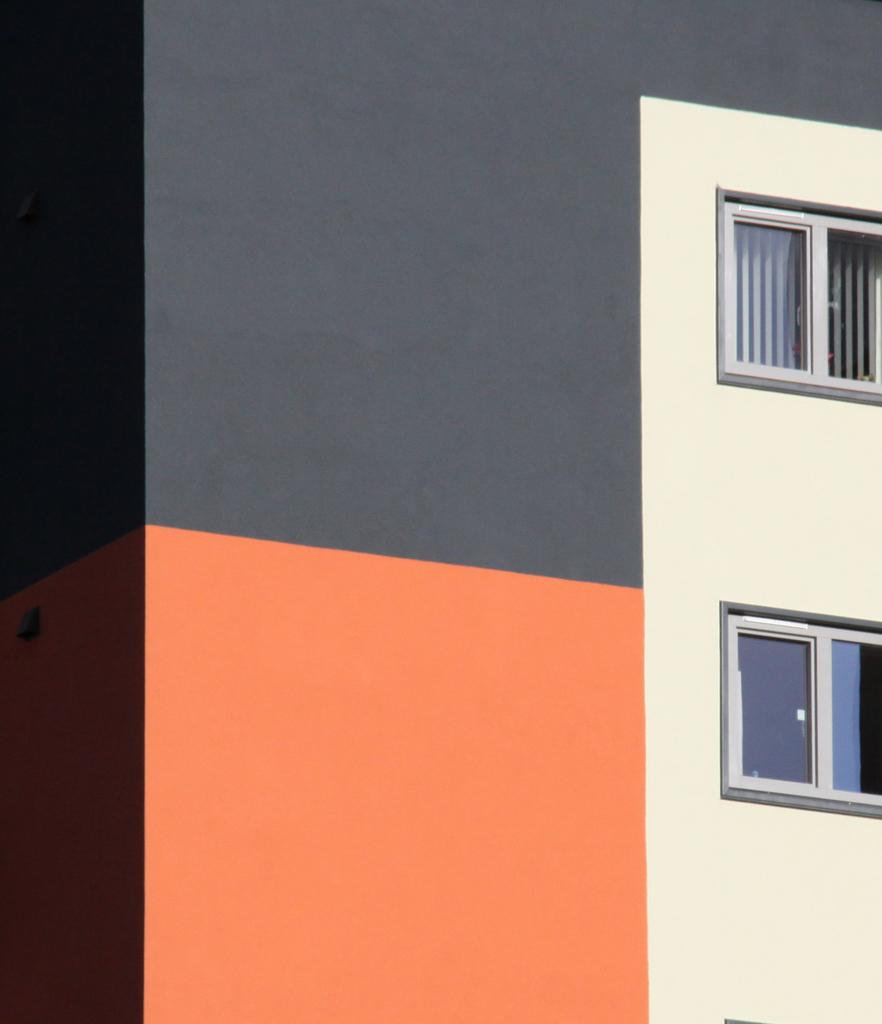How many windows are visible in the image? There are two windows in the image. Where are the windows located? The windows are on a building wall. Is there a dock visible near the windows in the image? No, there is no dock present in the image. 